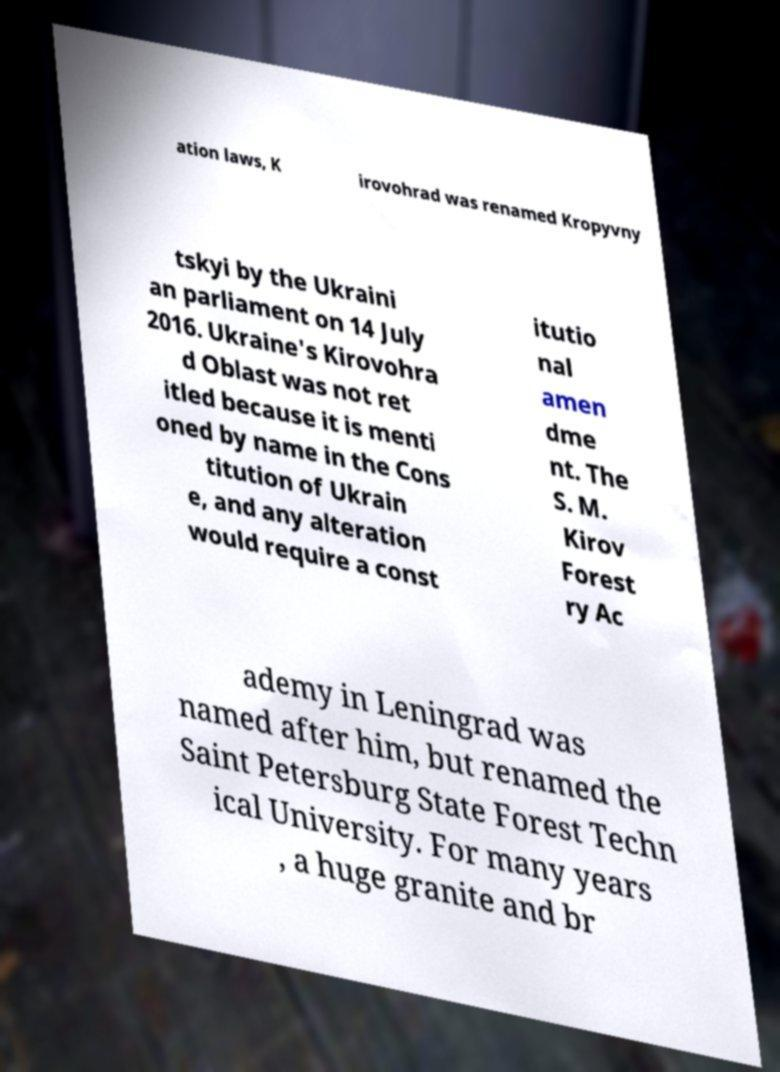Please read and relay the text visible in this image. What does it say? ation laws, K irovohrad was renamed Kropyvny tskyi by the Ukraini an parliament on 14 July 2016. Ukraine's Kirovohra d Oblast was not ret itled because it is menti oned by name in the Cons titution of Ukrain e, and any alteration would require a const itutio nal amen dme nt. The S. M. Kirov Forest ry Ac ademy in Leningrad was named after him, but renamed the Saint Petersburg State Forest Techn ical University. For many years , a huge granite and br 